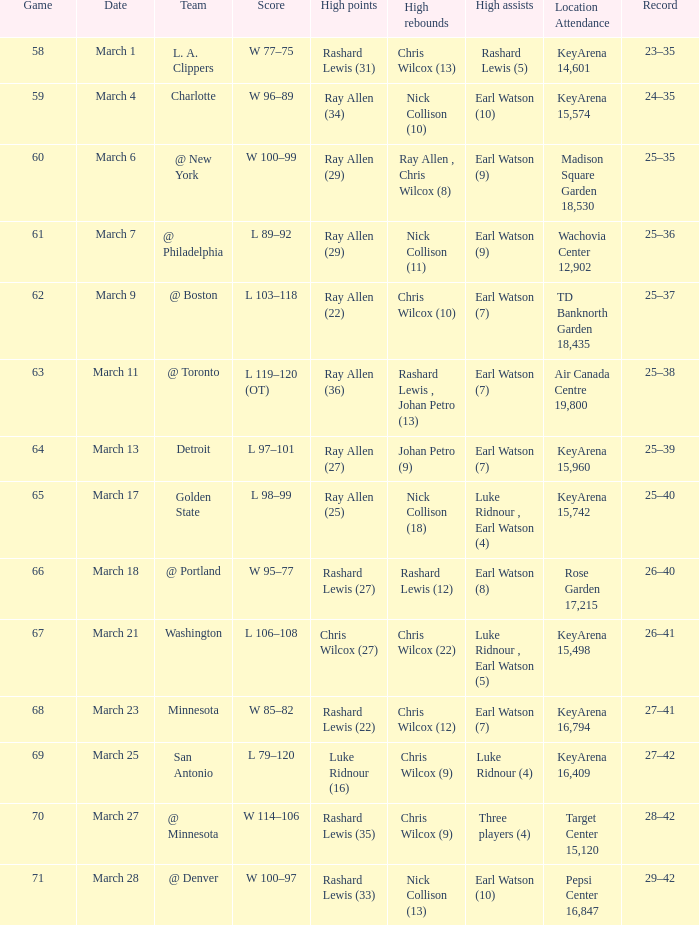What was the record after the game against Washington? 26–41. I'm looking to parse the entire table for insights. Could you assist me with that? {'header': ['Game', 'Date', 'Team', 'Score', 'High points', 'High rebounds', 'High assists', 'Location Attendance', 'Record'], 'rows': [['58', 'March 1', 'L. A. Clippers', 'W 77–75', 'Rashard Lewis (31)', 'Chris Wilcox (13)', 'Rashard Lewis (5)', 'KeyArena 14,601', '23–35'], ['59', 'March 4', 'Charlotte', 'W 96–89', 'Ray Allen (34)', 'Nick Collison (10)', 'Earl Watson (10)', 'KeyArena 15,574', '24–35'], ['60', 'March 6', '@ New York', 'W 100–99', 'Ray Allen (29)', 'Ray Allen , Chris Wilcox (8)', 'Earl Watson (9)', 'Madison Square Garden 18,530', '25–35'], ['61', 'March 7', '@ Philadelphia', 'L 89–92', 'Ray Allen (29)', 'Nick Collison (11)', 'Earl Watson (9)', 'Wachovia Center 12,902', '25–36'], ['62', 'March 9', '@ Boston', 'L 103–118', 'Ray Allen (22)', 'Chris Wilcox (10)', 'Earl Watson (7)', 'TD Banknorth Garden 18,435', '25–37'], ['63', 'March 11', '@ Toronto', 'L 119–120 (OT)', 'Ray Allen (36)', 'Rashard Lewis , Johan Petro (13)', 'Earl Watson (7)', 'Air Canada Centre 19,800', '25–38'], ['64', 'March 13', 'Detroit', 'L 97–101', 'Ray Allen (27)', 'Johan Petro (9)', 'Earl Watson (7)', 'KeyArena 15,960', '25–39'], ['65', 'March 17', 'Golden State', 'L 98–99', 'Ray Allen (25)', 'Nick Collison (18)', 'Luke Ridnour , Earl Watson (4)', 'KeyArena 15,742', '25–40'], ['66', 'March 18', '@ Portland', 'W 95–77', 'Rashard Lewis (27)', 'Rashard Lewis (12)', 'Earl Watson (8)', 'Rose Garden 17,215', '26–40'], ['67', 'March 21', 'Washington', 'L 106–108', 'Chris Wilcox (27)', 'Chris Wilcox (22)', 'Luke Ridnour , Earl Watson (5)', 'KeyArena 15,498', '26–41'], ['68', 'March 23', 'Minnesota', 'W 85–82', 'Rashard Lewis (22)', 'Chris Wilcox (12)', 'Earl Watson (7)', 'KeyArena 16,794', '27–41'], ['69', 'March 25', 'San Antonio', 'L 79–120', 'Luke Ridnour (16)', 'Chris Wilcox (9)', 'Luke Ridnour (4)', 'KeyArena 16,409', '27–42'], ['70', 'March 27', '@ Minnesota', 'W 114–106', 'Rashard Lewis (35)', 'Chris Wilcox (9)', 'Three players (4)', 'Target Center 15,120', '28–42'], ['71', 'March 28', '@ Denver', 'W 100–97', 'Rashard Lewis (33)', 'Nick Collison (13)', 'Earl Watson (10)', 'Pepsi Center 16,847', '29–42']]} 